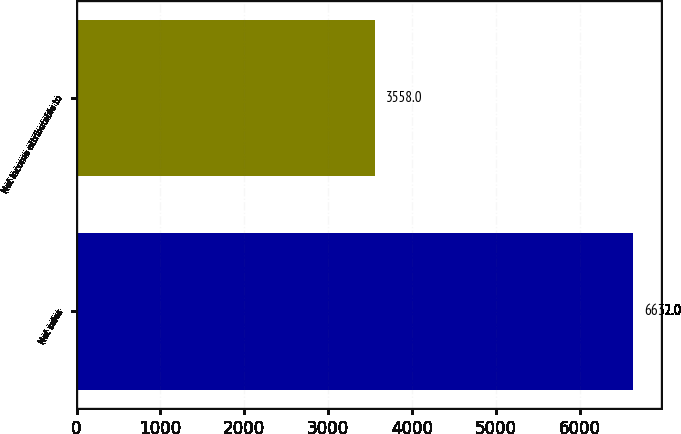Convert chart to OTSL. <chart><loc_0><loc_0><loc_500><loc_500><bar_chart><fcel>Net sales<fcel>Net income attributable to<nl><fcel>6632<fcel>3558<nl></chart> 